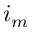<formula> <loc_0><loc_0><loc_500><loc_500>i _ { m }</formula> 